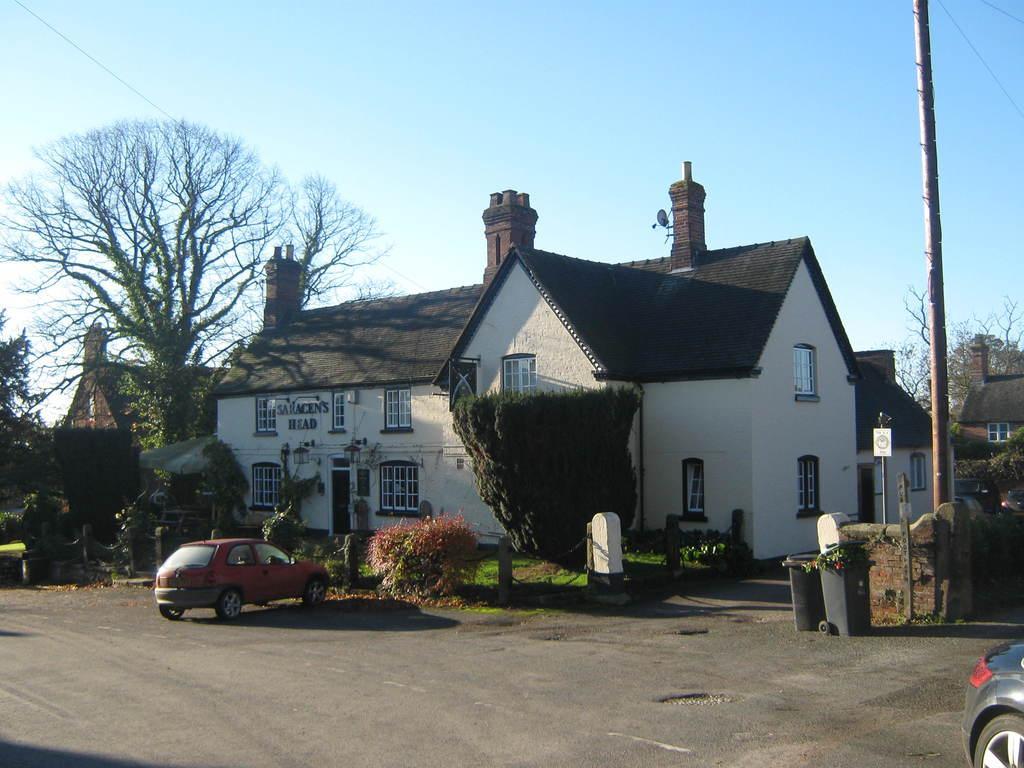Can you describe this image briefly? At the bottom of the picture, we see the road. In the middle, we see the red car parked on the road. Beside that, we see the poles, shrubs, grass and the trees. In the middle, we see a building in white color with a grey color roof. On the right side, we see a wall, poles, trees and a board in white color with some text written on it. There are trees and the buildings in the background. At the top, we see the sky. 